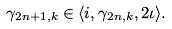<formula> <loc_0><loc_0><loc_500><loc_500>\gamma _ { 2 n + 1 , k } \in \langle i , \gamma _ { 2 n , k } , 2 \iota \rangle .</formula> 